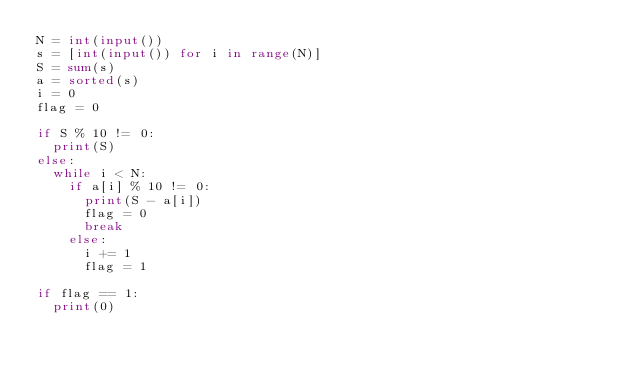Convert code to text. <code><loc_0><loc_0><loc_500><loc_500><_Python_>N = int(input())
s = [int(input()) for i in range(N)]
S = sum(s)
a = sorted(s)
i = 0
flag = 0

if S % 10 != 0:
	print(S)
else:
	while i < N:
		if a[i] % 10 != 0:
			print(S - a[i])
			flag = 0
			break
		else:
			i += 1
			flag = 1

if flag == 1:
	print(0)
</code> 